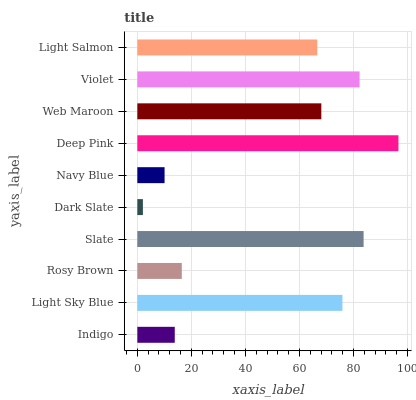Is Dark Slate the minimum?
Answer yes or no. Yes. Is Deep Pink the maximum?
Answer yes or no. Yes. Is Light Sky Blue the minimum?
Answer yes or no. No. Is Light Sky Blue the maximum?
Answer yes or no. No. Is Light Sky Blue greater than Indigo?
Answer yes or no. Yes. Is Indigo less than Light Sky Blue?
Answer yes or no. Yes. Is Indigo greater than Light Sky Blue?
Answer yes or no. No. Is Light Sky Blue less than Indigo?
Answer yes or no. No. Is Web Maroon the high median?
Answer yes or no. Yes. Is Light Salmon the low median?
Answer yes or no. Yes. Is Dark Slate the high median?
Answer yes or no. No. Is Deep Pink the low median?
Answer yes or no. No. 